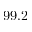<formula> <loc_0><loc_0><loc_500><loc_500>9 9 . 2</formula> 